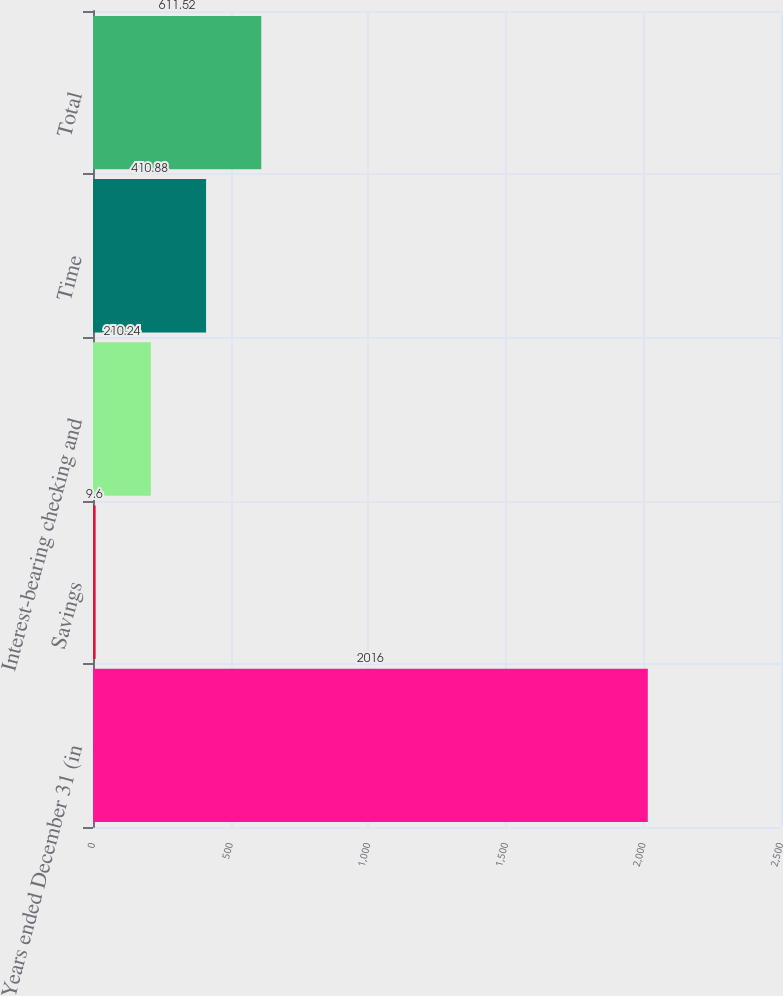Convert chart. <chart><loc_0><loc_0><loc_500><loc_500><bar_chart><fcel>Years ended December 31 (in<fcel>Savings<fcel>Interest-bearing checking and<fcel>Time<fcel>Total<nl><fcel>2016<fcel>9.6<fcel>210.24<fcel>410.88<fcel>611.52<nl></chart> 